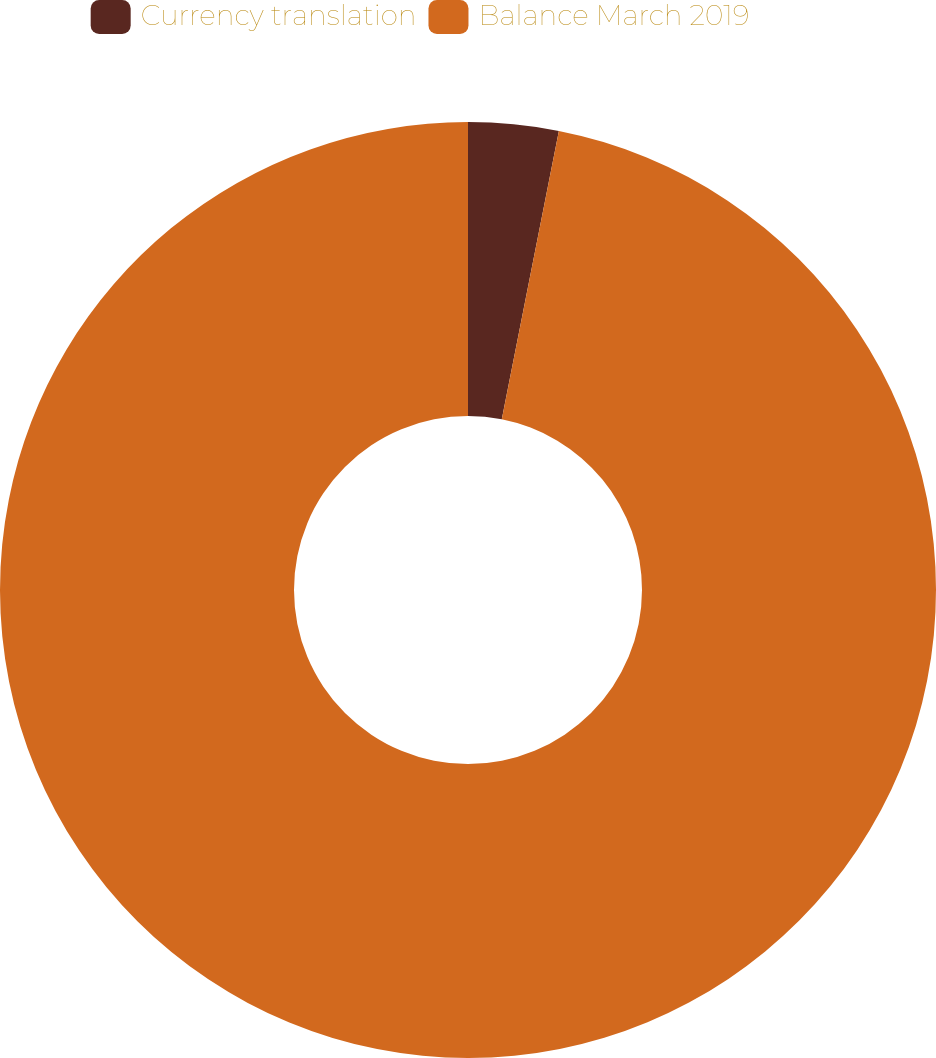<chart> <loc_0><loc_0><loc_500><loc_500><pie_chart><fcel>Currency translation<fcel>Balance March 2019<nl><fcel>3.11%<fcel>96.89%<nl></chart> 